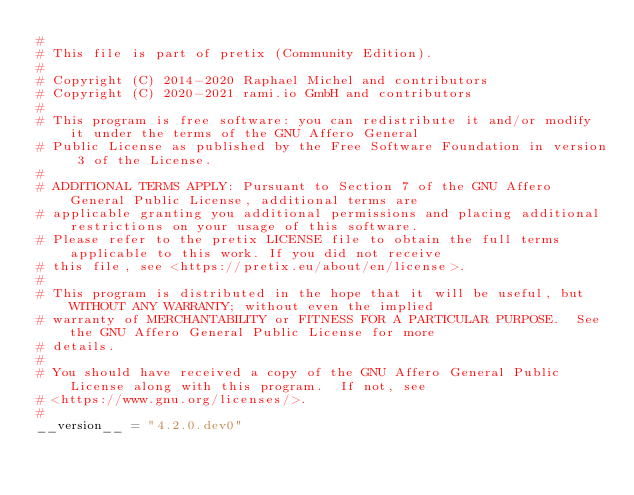Convert code to text. <code><loc_0><loc_0><loc_500><loc_500><_Python_>#
# This file is part of pretix (Community Edition).
#
# Copyright (C) 2014-2020 Raphael Michel and contributors
# Copyright (C) 2020-2021 rami.io GmbH and contributors
#
# This program is free software: you can redistribute it and/or modify it under the terms of the GNU Affero General
# Public License as published by the Free Software Foundation in version 3 of the License.
#
# ADDITIONAL TERMS APPLY: Pursuant to Section 7 of the GNU Affero General Public License, additional terms are
# applicable granting you additional permissions and placing additional restrictions on your usage of this software.
# Please refer to the pretix LICENSE file to obtain the full terms applicable to this work. If you did not receive
# this file, see <https://pretix.eu/about/en/license>.
#
# This program is distributed in the hope that it will be useful, but WITHOUT ANY WARRANTY; without even the implied
# warranty of MERCHANTABILITY or FITNESS FOR A PARTICULAR PURPOSE.  See the GNU Affero General Public License for more
# details.
#
# You should have received a copy of the GNU Affero General Public License along with this program.  If not, see
# <https://www.gnu.org/licenses/>.
#
__version__ = "4.2.0.dev0"
</code> 